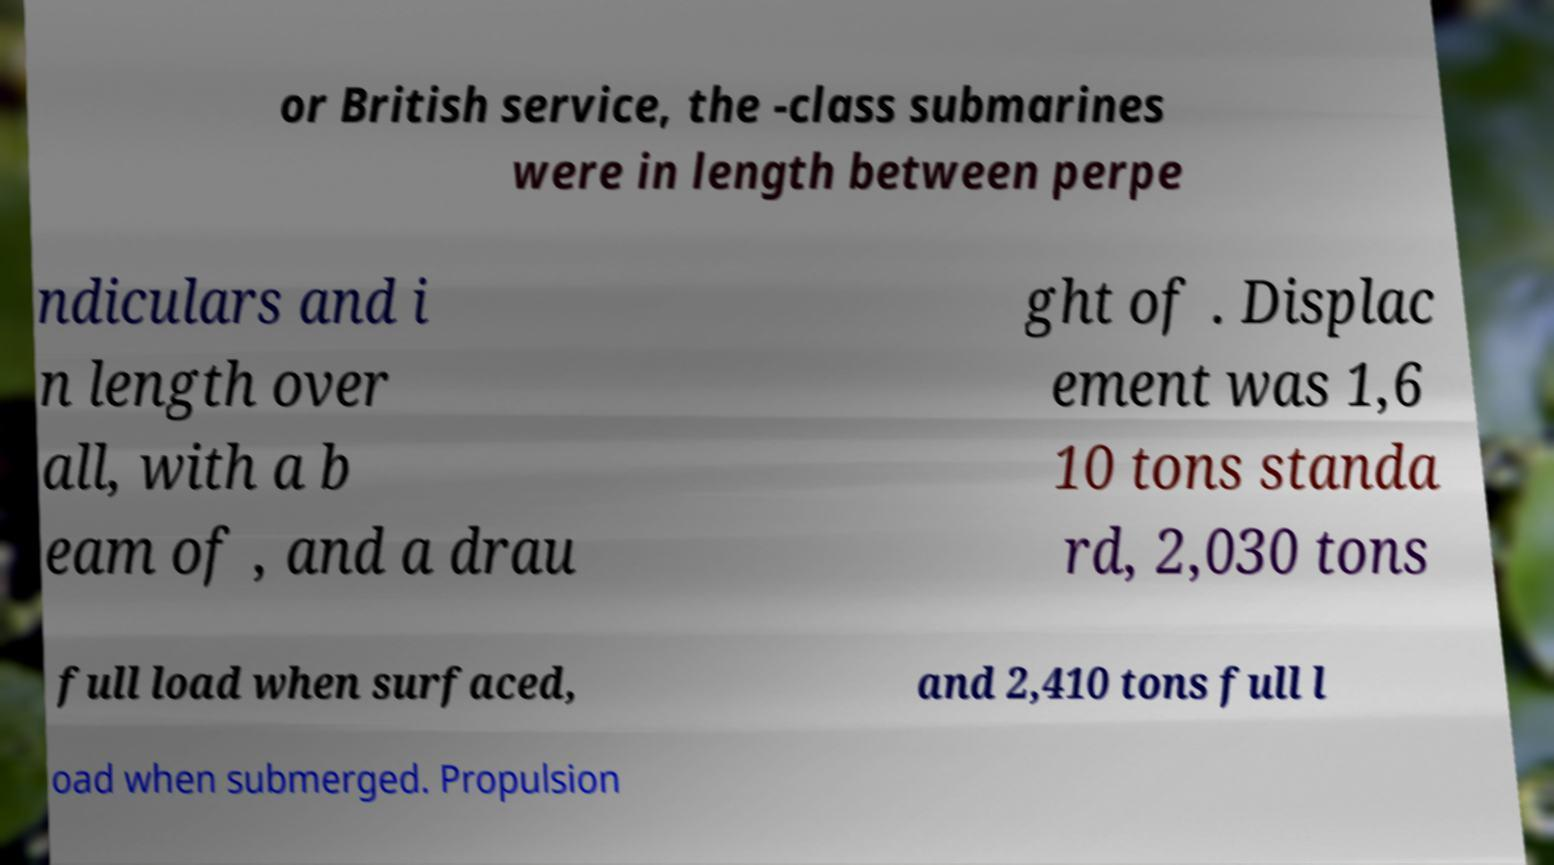Could you assist in decoding the text presented in this image and type it out clearly? or British service, the -class submarines were in length between perpe ndiculars and i n length over all, with a b eam of , and a drau ght of . Displac ement was 1,6 10 tons standa rd, 2,030 tons full load when surfaced, and 2,410 tons full l oad when submerged. Propulsion 